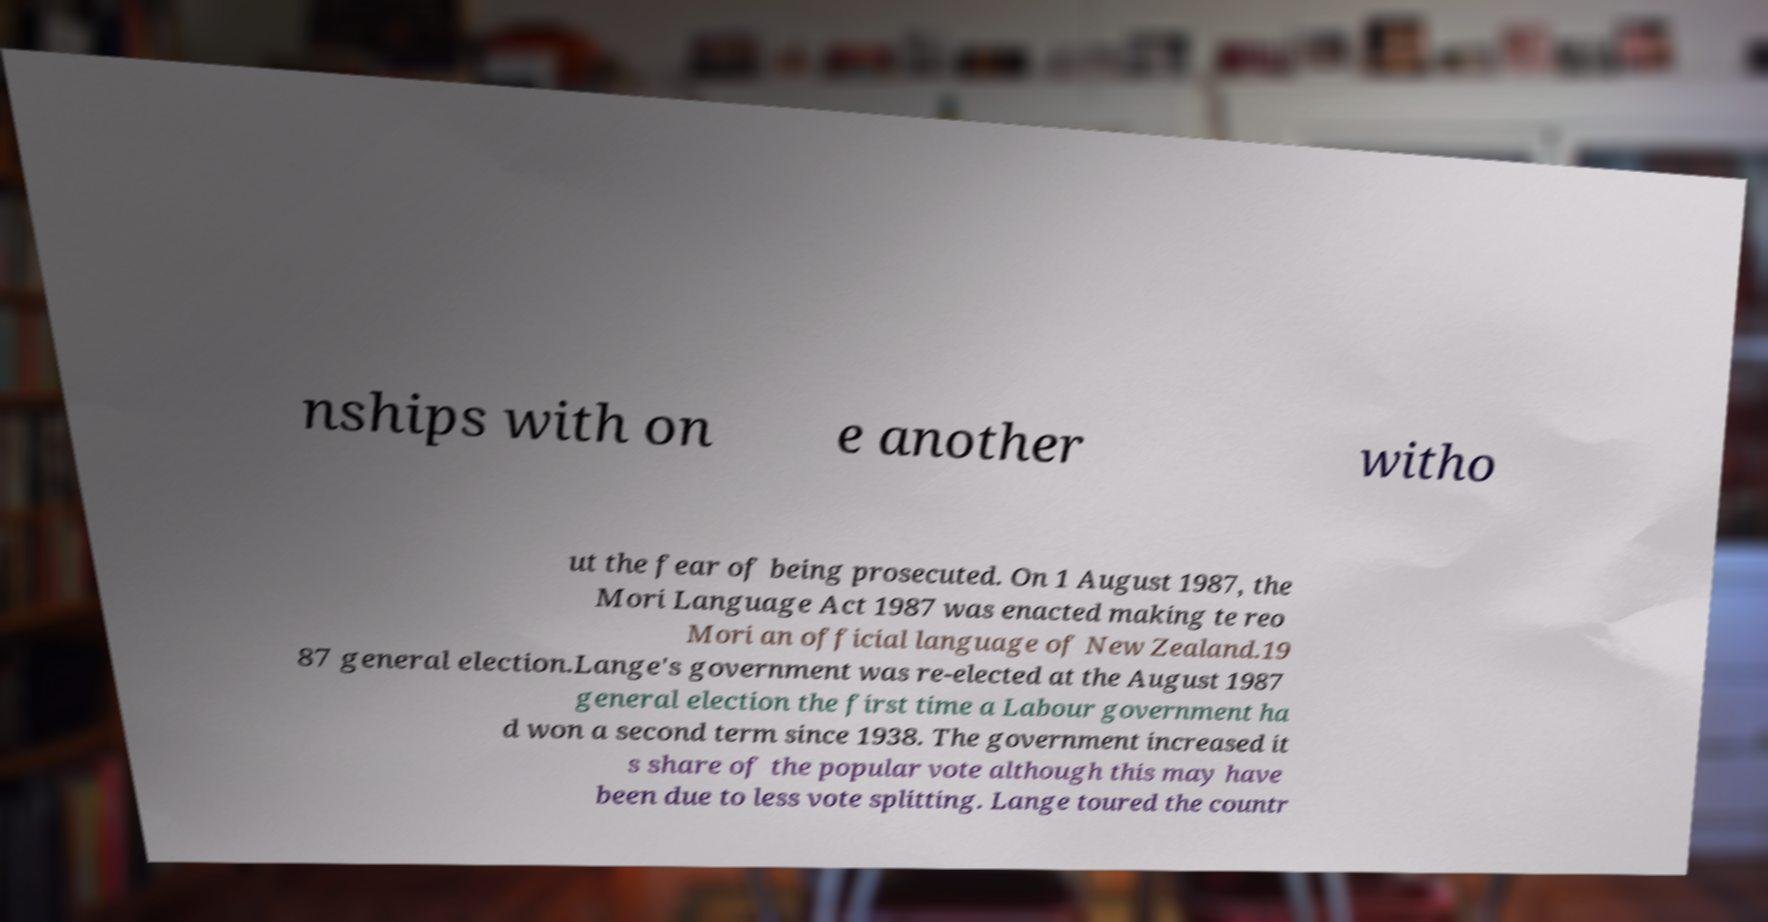Please identify and transcribe the text found in this image. nships with on e another witho ut the fear of being prosecuted. On 1 August 1987, the Mori Language Act 1987 was enacted making te reo Mori an official language of New Zealand.19 87 general election.Lange's government was re-elected at the August 1987 general election the first time a Labour government ha d won a second term since 1938. The government increased it s share of the popular vote although this may have been due to less vote splitting. Lange toured the countr 